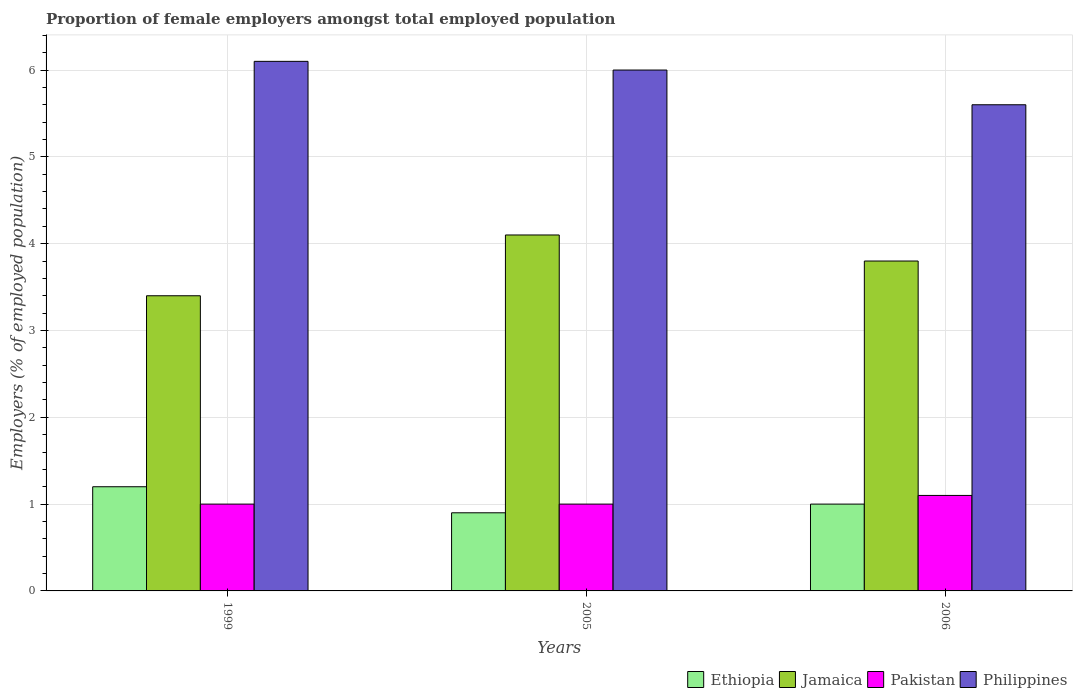How many groups of bars are there?
Your answer should be compact. 3. Are the number of bars per tick equal to the number of legend labels?
Make the answer very short. Yes. How many bars are there on the 2nd tick from the left?
Your response must be concise. 4. In how many cases, is the number of bars for a given year not equal to the number of legend labels?
Offer a very short reply. 0. Across all years, what is the maximum proportion of female employers in Pakistan?
Your answer should be compact. 1.1. Across all years, what is the minimum proportion of female employers in Pakistan?
Provide a succinct answer. 1. In which year was the proportion of female employers in Pakistan maximum?
Give a very brief answer. 2006. What is the total proportion of female employers in Pakistan in the graph?
Make the answer very short. 3.1. What is the difference between the proportion of female employers in Philippines in 1999 and that in 2005?
Your answer should be compact. 0.1. What is the difference between the proportion of female employers in Ethiopia in 2006 and the proportion of female employers in Jamaica in 1999?
Provide a succinct answer. -2.4. What is the average proportion of female employers in Philippines per year?
Ensure brevity in your answer.  5.9. In the year 1999, what is the difference between the proportion of female employers in Ethiopia and proportion of female employers in Philippines?
Your answer should be compact. -4.9. In how many years, is the proportion of female employers in Pakistan greater than 5 %?
Ensure brevity in your answer.  0. What is the ratio of the proportion of female employers in Jamaica in 1999 to that in 2005?
Your answer should be compact. 0.83. Is the difference between the proportion of female employers in Ethiopia in 2005 and 2006 greater than the difference between the proportion of female employers in Philippines in 2005 and 2006?
Offer a terse response. No. What is the difference between the highest and the second highest proportion of female employers in Ethiopia?
Your response must be concise. 0.2. What is the difference between the highest and the lowest proportion of female employers in Philippines?
Offer a very short reply. 0.5. Is the sum of the proportion of female employers in Pakistan in 2005 and 2006 greater than the maximum proportion of female employers in Jamaica across all years?
Make the answer very short. No. What does the 4th bar from the left in 2005 represents?
Offer a very short reply. Philippines. How many years are there in the graph?
Your answer should be very brief. 3. Does the graph contain any zero values?
Your response must be concise. No. Does the graph contain grids?
Your answer should be very brief. Yes. Where does the legend appear in the graph?
Make the answer very short. Bottom right. How are the legend labels stacked?
Your response must be concise. Horizontal. What is the title of the graph?
Keep it short and to the point. Proportion of female employers amongst total employed population. Does "Curacao" appear as one of the legend labels in the graph?
Your answer should be very brief. No. What is the label or title of the Y-axis?
Your response must be concise. Employers (% of employed population). What is the Employers (% of employed population) of Ethiopia in 1999?
Your response must be concise. 1.2. What is the Employers (% of employed population) in Jamaica in 1999?
Give a very brief answer. 3.4. What is the Employers (% of employed population) in Pakistan in 1999?
Keep it short and to the point. 1. What is the Employers (% of employed population) in Philippines in 1999?
Your response must be concise. 6.1. What is the Employers (% of employed population) in Ethiopia in 2005?
Keep it short and to the point. 0.9. What is the Employers (% of employed population) in Jamaica in 2005?
Keep it short and to the point. 4.1. What is the Employers (% of employed population) in Philippines in 2005?
Keep it short and to the point. 6. What is the Employers (% of employed population) in Ethiopia in 2006?
Provide a short and direct response. 1. What is the Employers (% of employed population) of Jamaica in 2006?
Make the answer very short. 3.8. What is the Employers (% of employed population) in Pakistan in 2006?
Provide a short and direct response. 1.1. What is the Employers (% of employed population) of Philippines in 2006?
Make the answer very short. 5.6. Across all years, what is the maximum Employers (% of employed population) of Ethiopia?
Your answer should be very brief. 1.2. Across all years, what is the maximum Employers (% of employed population) of Jamaica?
Your answer should be compact. 4.1. Across all years, what is the maximum Employers (% of employed population) in Pakistan?
Make the answer very short. 1.1. Across all years, what is the maximum Employers (% of employed population) in Philippines?
Provide a succinct answer. 6.1. Across all years, what is the minimum Employers (% of employed population) of Ethiopia?
Your answer should be compact. 0.9. Across all years, what is the minimum Employers (% of employed population) in Jamaica?
Make the answer very short. 3.4. Across all years, what is the minimum Employers (% of employed population) in Philippines?
Offer a terse response. 5.6. What is the total Employers (% of employed population) in Jamaica in the graph?
Provide a short and direct response. 11.3. What is the difference between the Employers (% of employed population) in Ethiopia in 1999 and that in 2005?
Keep it short and to the point. 0.3. What is the difference between the Employers (% of employed population) in Jamaica in 1999 and that in 2005?
Give a very brief answer. -0.7. What is the difference between the Employers (% of employed population) in Pakistan in 1999 and that in 2005?
Make the answer very short. 0. What is the difference between the Employers (% of employed population) in Philippines in 1999 and that in 2005?
Provide a short and direct response. 0.1. What is the difference between the Employers (% of employed population) in Jamaica in 1999 and that in 2006?
Make the answer very short. -0.4. What is the difference between the Employers (% of employed population) of Pakistan in 1999 and that in 2006?
Make the answer very short. -0.1. What is the difference between the Employers (% of employed population) of Pakistan in 2005 and that in 2006?
Keep it short and to the point. -0.1. What is the difference between the Employers (% of employed population) of Ethiopia in 1999 and the Employers (% of employed population) of Jamaica in 2005?
Your response must be concise. -2.9. What is the difference between the Employers (% of employed population) of Jamaica in 1999 and the Employers (% of employed population) of Pakistan in 2005?
Offer a terse response. 2.4. What is the difference between the Employers (% of employed population) of Jamaica in 1999 and the Employers (% of employed population) of Philippines in 2005?
Provide a short and direct response. -2.6. What is the difference between the Employers (% of employed population) in Pakistan in 1999 and the Employers (% of employed population) in Philippines in 2005?
Provide a short and direct response. -5. What is the difference between the Employers (% of employed population) of Ethiopia in 1999 and the Employers (% of employed population) of Jamaica in 2006?
Your answer should be very brief. -2.6. What is the difference between the Employers (% of employed population) of Jamaica in 1999 and the Employers (% of employed population) of Pakistan in 2006?
Give a very brief answer. 2.3. What is the difference between the Employers (% of employed population) in Jamaica in 1999 and the Employers (% of employed population) in Philippines in 2006?
Provide a short and direct response. -2.2. What is the difference between the Employers (% of employed population) of Ethiopia in 2005 and the Employers (% of employed population) of Jamaica in 2006?
Your response must be concise. -2.9. What is the difference between the Employers (% of employed population) of Ethiopia in 2005 and the Employers (% of employed population) of Pakistan in 2006?
Make the answer very short. -0.2. What is the difference between the Employers (% of employed population) in Ethiopia in 2005 and the Employers (% of employed population) in Philippines in 2006?
Provide a short and direct response. -4.7. What is the difference between the Employers (% of employed population) in Jamaica in 2005 and the Employers (% of employed population) in Philippines in 2006?
Ensure brevity in your answer.  -1.5. What is the average Employers (% of employed population) of Ethiopia per year?
Ensure brevity in your answer.  1.03. What is the average Employers (% of employed population) of Jamaica per year?
Provide a succinct answer. 3.77. What is the average Employers (% of employed population) in Pakistan per year?
Provide a succinct answer. 1.03. In the year 1999, what is the difference between the Employers (% of employed population) in Ethiopia and Employers (% of employed population) in Jamaica?
Ensure brevity in your answer.  -2.2. In the year 1999, what is the difference between the Employers (% of employed population) in Ethiopia and Employers (% of employed population) in Pakistan?
Keep it short and to the point. 0.2. In the year 1999, what is the difference between the Employers (% of employed population) of Ethiopia and Employers (% of employed population) of Philippines?
Keep it short and to the point. -4.9. In the year 1999, what is the difference between the Employers (% of employed population) in Jamaica and Employers (% of employed population) in Philippines?
Your answer should be very brief. -2.7. In the year 2005, what is the difference between the Employers (% of employed population) in Ethiopia and Employers (% of employed population) in Jamaica?
Ensure brevity in your answer.  -3.2. In the year 2005, what is the difference between the Employers (% of employed population) of Ethiopia and Employers (% of employed population) of Pakistan?
Offer a terse response. -0.1. In the year 2005, what is the difference between the Employers (% of employed population) of Jamaica and Employers (% of employed population) of Pakistan?
Ensure brevity in your answer.  3.1. In the year 2005, what is the difference between the Employers (% of employed population) of Pakistan and Employers (% of employed population) of Philippines?
Your response must be concise. -5. In the year 2006, what is the difference between the Employers (% of employed population) of Ethiopia and Employers (% of employed population) of Pakistan?
Make the answer very short. -0.1. In the year 2006, what is the difference between the Employers (% of employed population) of Ethiopia and Employers (% of employed population) of Philippines?
Offer a very short reply. -4.6. In the year 2006, what is the difference between the Employers (% of employed population) of Jamaica and Employers (% of employed population) of Pakistan?
Provide a short and direct response. 2.7. In the year 2006, what is the difference between the Employers (% of employed population) in Jamaica and Employers (% of employed population) in Philippines?
Your answer should be compact. -1.8. What is the ratio of the Employers (% of employed population) in Ethiopia in 1999 to that in 2005?
Keep it short and to the point. 1.33. What is the ratio of the Employers (% of employed population) of Jamaica in 1999 to that in 2005?
Ensure brevity in your answer.  0.83. What is the ratio of the Employers (% of employed population) in Philippines in 1999 to that in 2005?
Offer a very short reply. 1.02. What is the ratio of the Employers (% of employed population) of Jamaica in 1999 to that in 2006?
Give a very brief answer. 0.89. What is the ratio of the Employers (% of employed population) in Philippines in 1999 to that in 2006?
Make the answer very short. 1.09. What is the ratio of the Employers (% of employed population) of Jamaica in 2005 to that in 2006?
Your answer should be very brief. 1.08. What is the ratio of the Employers (% of employed population) of Philippines in 2005 to that in 2006?
Provide a short and direct response. 1.07. What is the difference between the highest and the second highest Employers (% of employed population) of Ethiopia?
Offer a terse response. 0.2. 